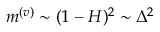<formula> <loc_0><loc_0><loc_500><loc_500>m ^ { ( v ) } \sim ( 1 - H ) ^ { 2 } \sim \Delta ^ { 2 }</formula> 